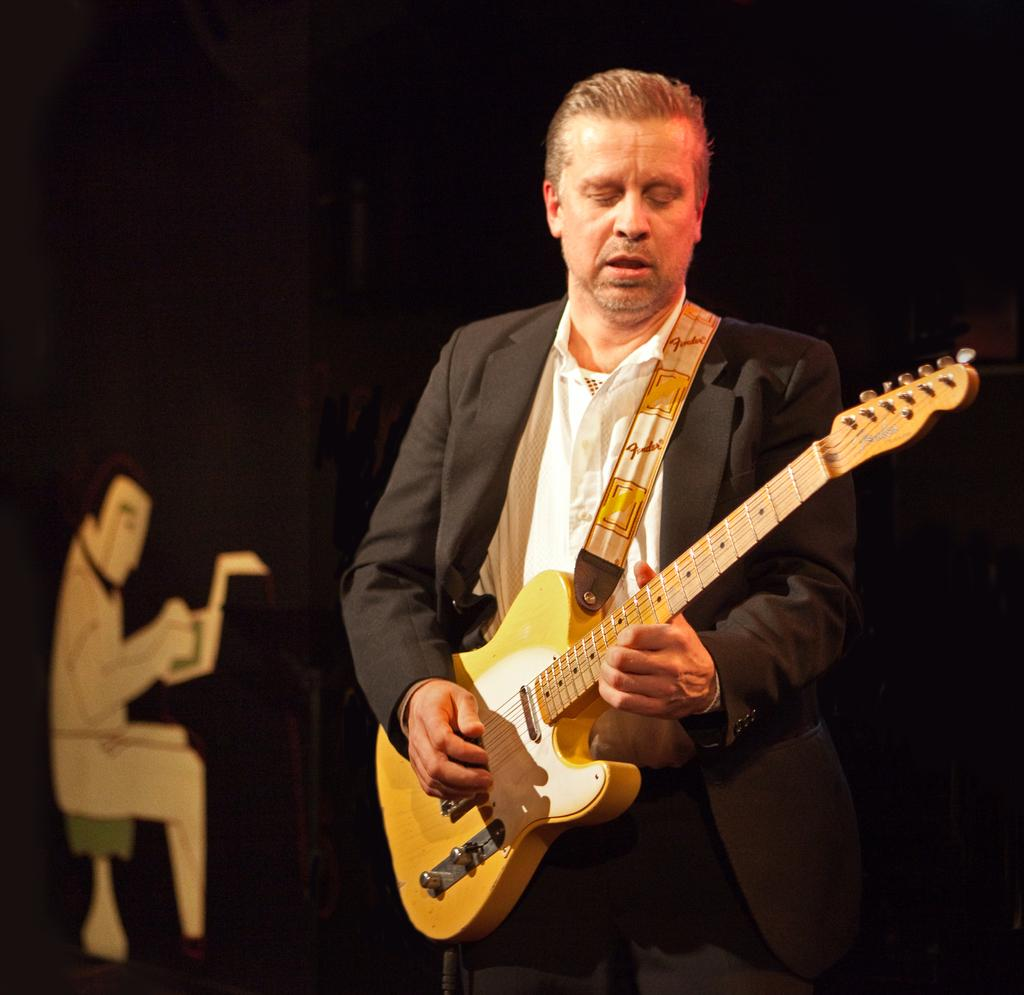What is the person in the image doing? The person is standing in the image and holding a guitar. What can be seen in the background of the image? There is a wall in the background of the image. How many lizards are crawling on the guitar in the image? There are no lizards present in the image; the person is holding a guitar without any lizards on it. 